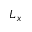Convert formula to latex. <formula><loc_0><loc_0><loc_500><loc_500>L _ { x }</formula> 